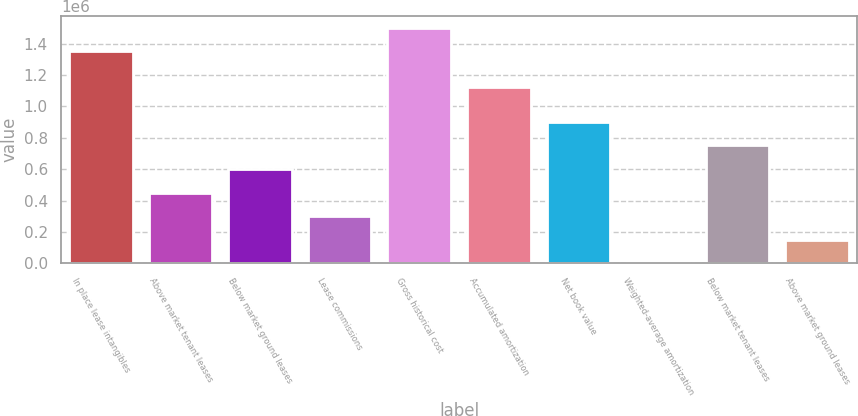Convert chart to OTSL. <chart><loc_0><loc_0><loc_500><loc_500><bar_chart><fcel>In place lease intangibles<fcel>Above market tenant leases<fcel>Below market ground leases<fcel>Lease commissions<fcel>Gross historical cost<fcel>Accumulated amortization<fcel>Net book value<fcel>Weighted-average amortization<fcel>Below market tenant leases<fcel>Above market ground leases<nl><fcel>1.35214e+06<fcel>450752<fcel>600997<fcel>300506<fcel>1.50247e+06<fcel>1.12544e+06<fcel>901489<fcel>15.1<fcel>751243<fcel>150261<nl></chart> 